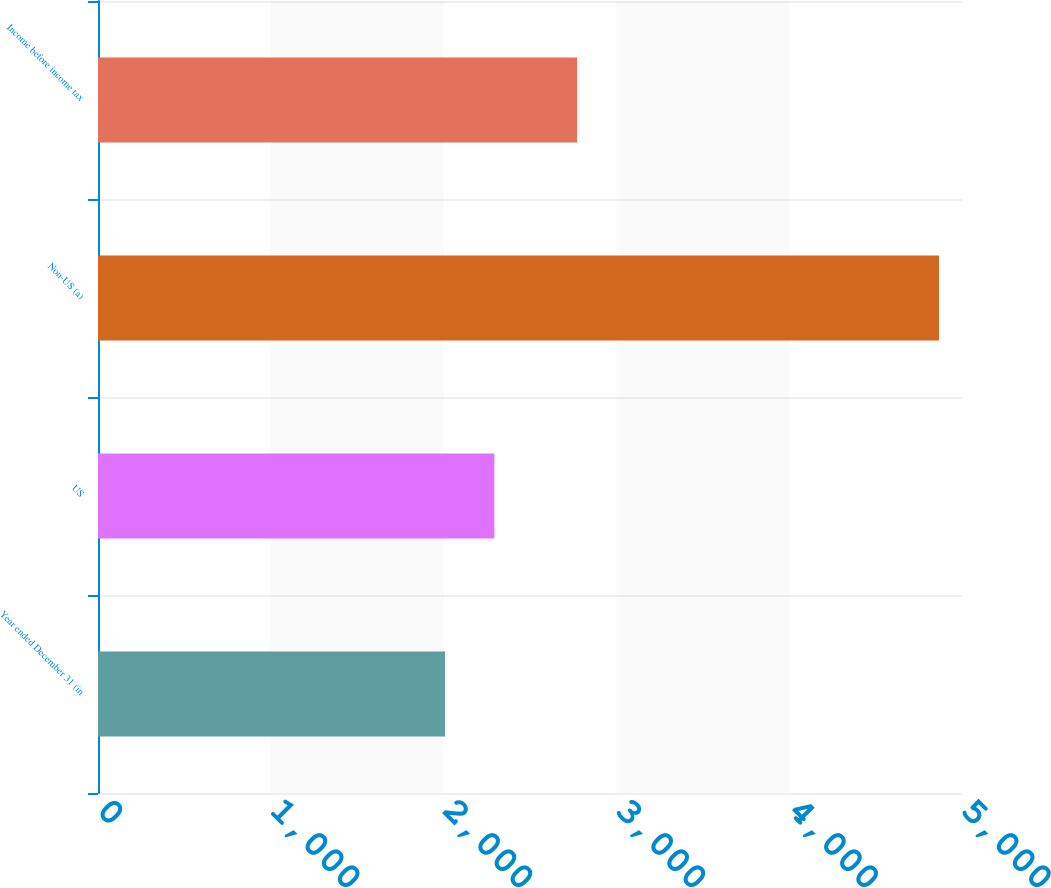Convert chart. <chart><loc_0><loc_0><loc_500><loc_500><bar_chart><fcel>Year ended December 31 (in<fcel>US<fcel>Non-US (a)<fcel>Income before income tax<nl><fcel>2008<fcel>2293.9<fcel>4867<fcel>2773<nl></chart> 